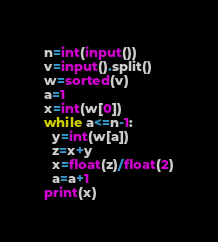Convert code to text. <code><loc_0><loc_0><loc_500><loc_500><_Python_>n=int(input())
v=input().split()
w=sorted(v)
a=1
x=int(w[0])
while a<=n-1:
  y=int(w[a])
  z=x+y
  x=float(z)/float(2)
  a=a+1
print(x)</code> 